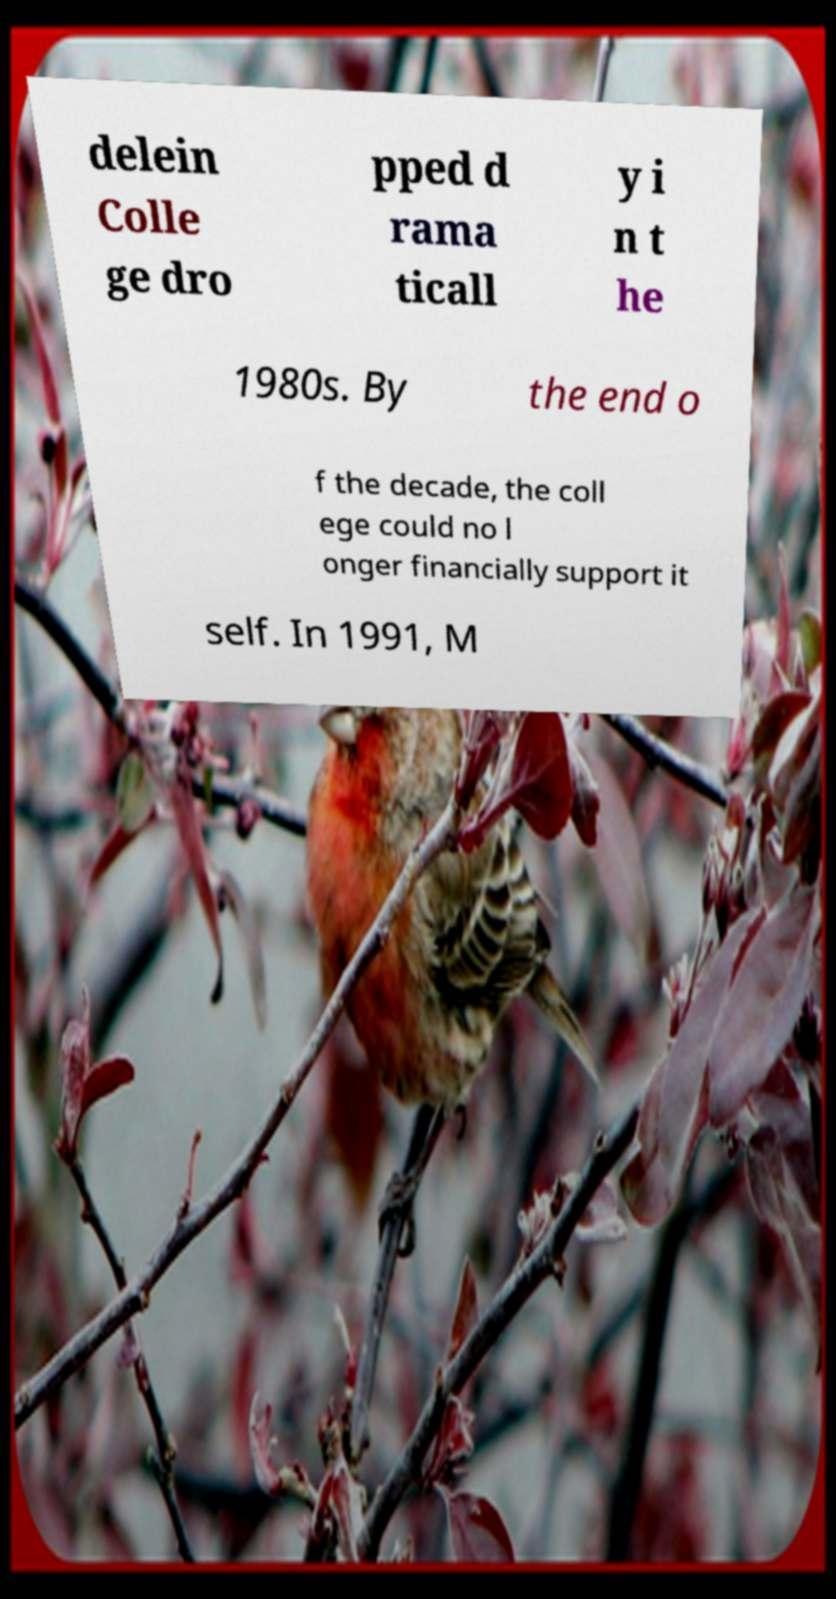Can you read and provide the text displayed in the image?This photo seems to have some interesting text. Can you extract and type it out for me? delein Colle ge dro pped d rama ticall y i n t he 1980s. By the end o f the decade, the coll ege could no l onger financially support it self. In 1991, M 